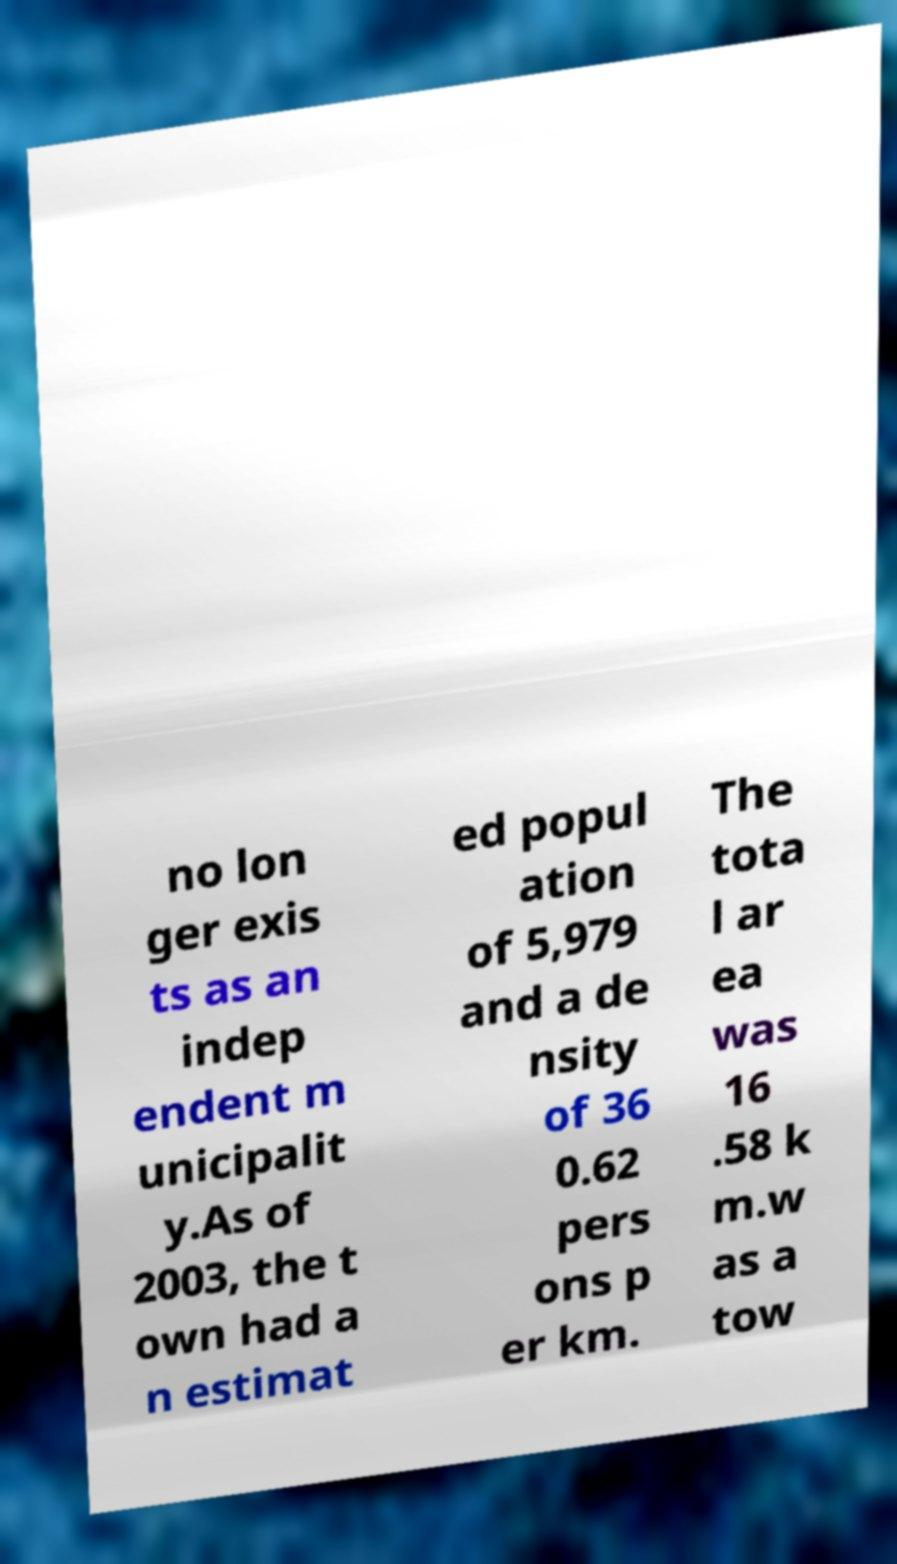There's text embedded in this image that I need extracted. Can you transcribe it verbatim? no lon ger exis ts as an indep endent m unicipalit y.As of 2003, the t own had a n estimat ed popul ation of 5,979 and a de nsity of 36 0.62 pers ons p er km. The tota l ar ea was 16 .58 k m.w as a tow 